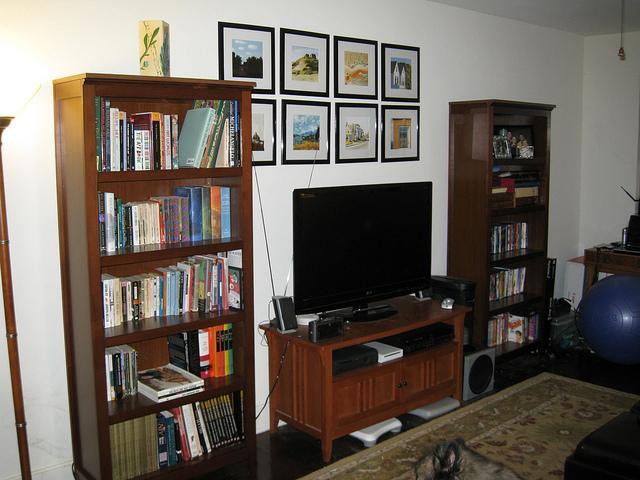What type of paint was used to paint the pictures hanging on the wall? Please explain your reasoning. watercolor. The semi translucent and smeary texture of the paintings in this living room identify them as water colors. 